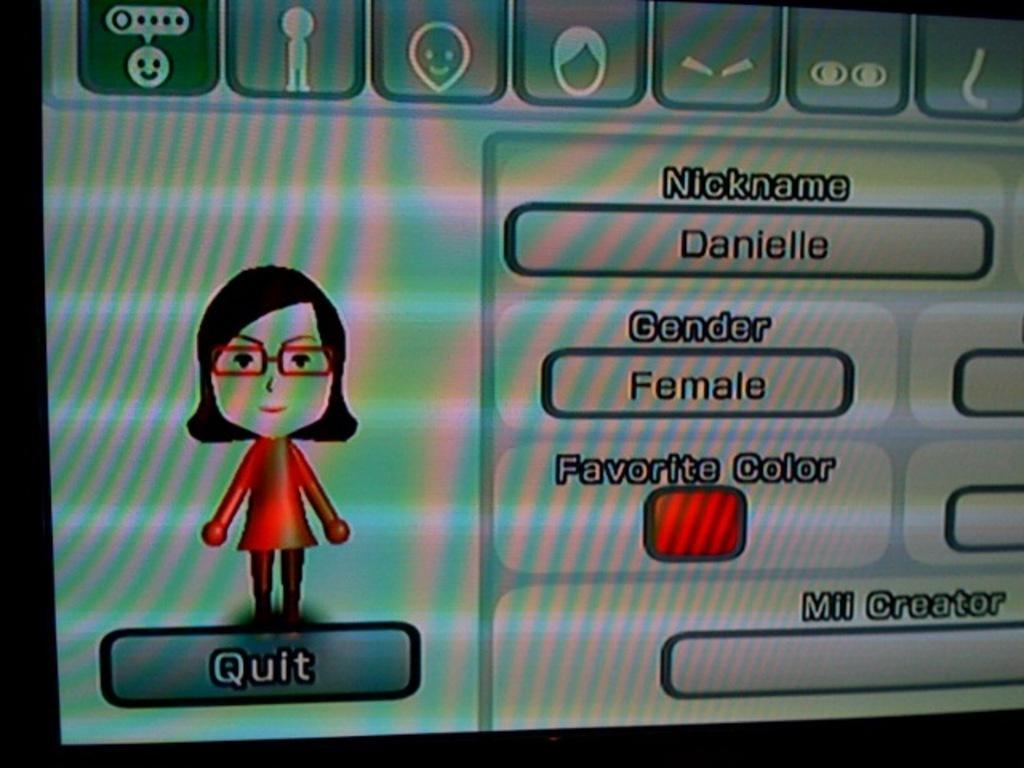Please provide a concise description of this image. In this image, we can see a monitor screen. On the screen, we can see a person and some text written on it. 